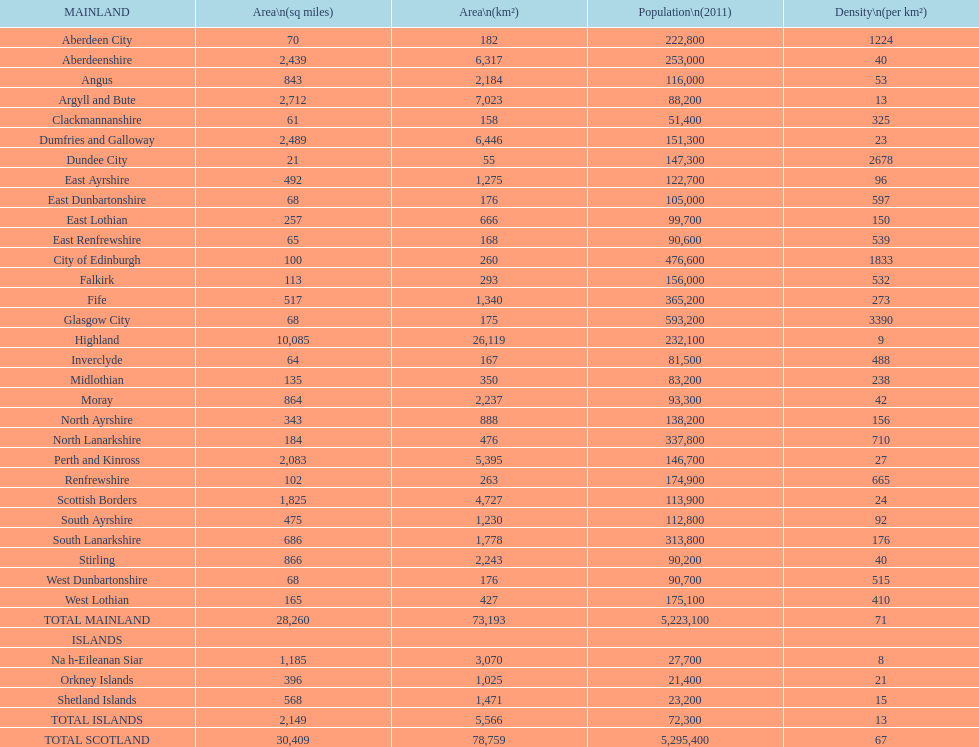Which specific subdivision surpasses argyll and bute in terms of area? Highland. 